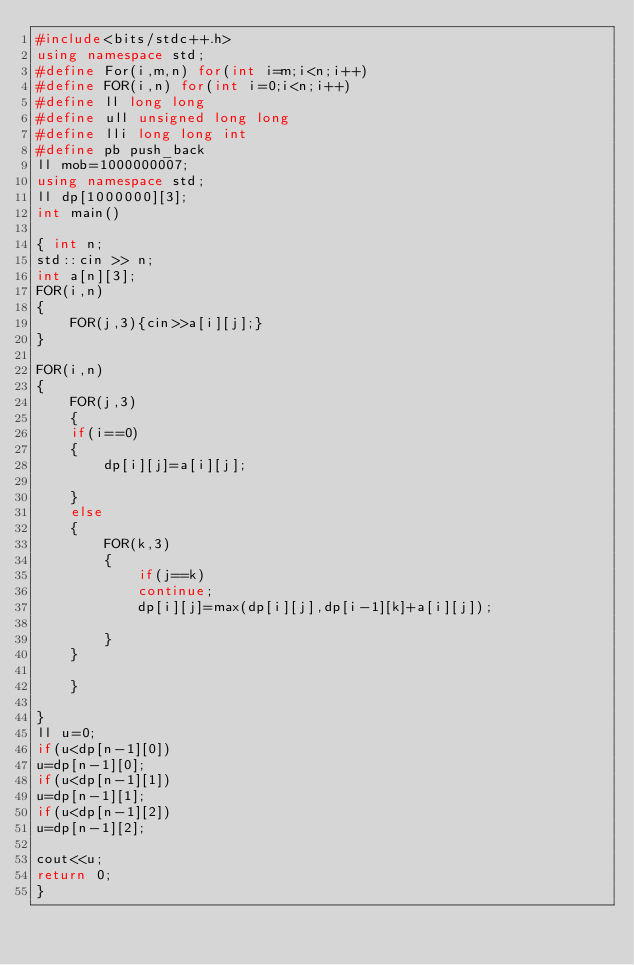Convert code to text. <code><loc_0><loc_0><loc_500><loc_500><_C++_>#include<bits/stdc++.h>
using namespace std;
#define For(i,m,n) for(int i=m;i<n;i++)
#define FOR(i,n) for(int i=0;i<n;i++)
#define ll long long
#define ull unsigned long long
#define lli long long int
#define pb push_back
ll mob=1000000007;
using namespace std;
ll dp[1000000][3];
int main()

{ int n;
std::cin >> n;
int a[n][3];
FOR(i,n)
{
    FOR(j,3){cin>>a[i][j];}
}

FOR(i,n)
{
    FOR(j,3)
    {
    if(i==0)
    {
        dp[i][j]=a[i][j];
        
    }
    else
    {
        FOR(k,3)
        {
            if(j==k)
            continue;
            dp[i][j]=max(dp[i][j],dp[i-1][k]+a[i][j]);
            
        }
    }
        
    }
    
}
ll u=0;
if(u<dp[n-1][0])
u=dp[n-1][0];
if(u<dp[n-1][1])
u=dp[n-1][1];
if(u<dp[n-1][2])
u=dp[n-1][2];

cout<<u;
return 0;
}








</code> 